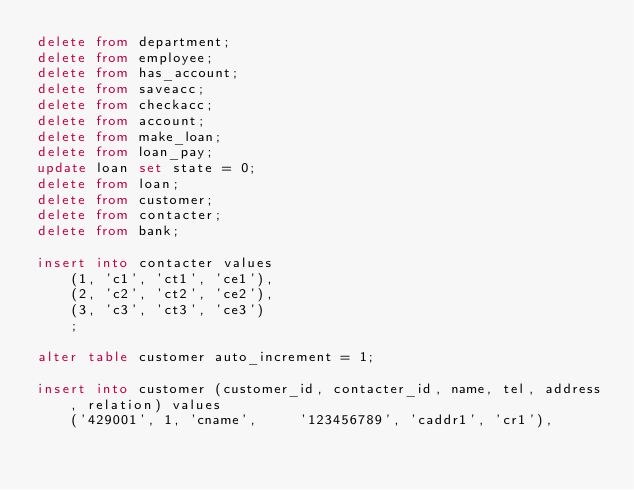<code> <loc_0><loc_0><loc_500><loc_500><_SQL_>delete from department;
delete from employee;
delete from has_account;
delete from saveacc;
delete from checkacc;
delete from account;
delete from make_loan;
delete from loan_pay;
update loan set state = 0;
delete from loan;
delete from customer;
delete from contacter;
delete from bank;

insert into contacter values
    (1, 'c1', 'ct1', 'ce1'),
    (2, 'c2', 'ct2', 'ce2'),
    (3, 'c3', 'ct3', 'ce3')
    ;

alter table customer auto_increment = 1;

insert into customer (customer_id, contacter_id, name, tel, address, relation) values
    ('429001', 1, 'cname',     '123456789', 'caddr1', 'cr1'),</code> 